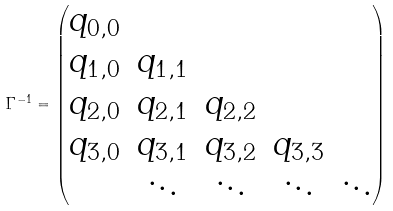Convert formula to latex. <formula><loc_0><loc_0><loc_500><loc_500>\Gamma ^ { - 1 } = \begin{pmatrix} q _ { 0 , 0 } & & & \\ q _ { 1 , 0 } & q _ { 1 , 1 } & & \\ q _ { 2 , 0 } & q _ { 2 , 1 } & q _ { 2 , 2 } & \\ q _ { 3 , 0 } & q _ { 3 , 1 } & q _ { 3 , 2 } & q _ { 3 , 3 } & \\ & \ddots & \ddots & \ddots & \ddots \\ \end{pmatrix}</formula> 